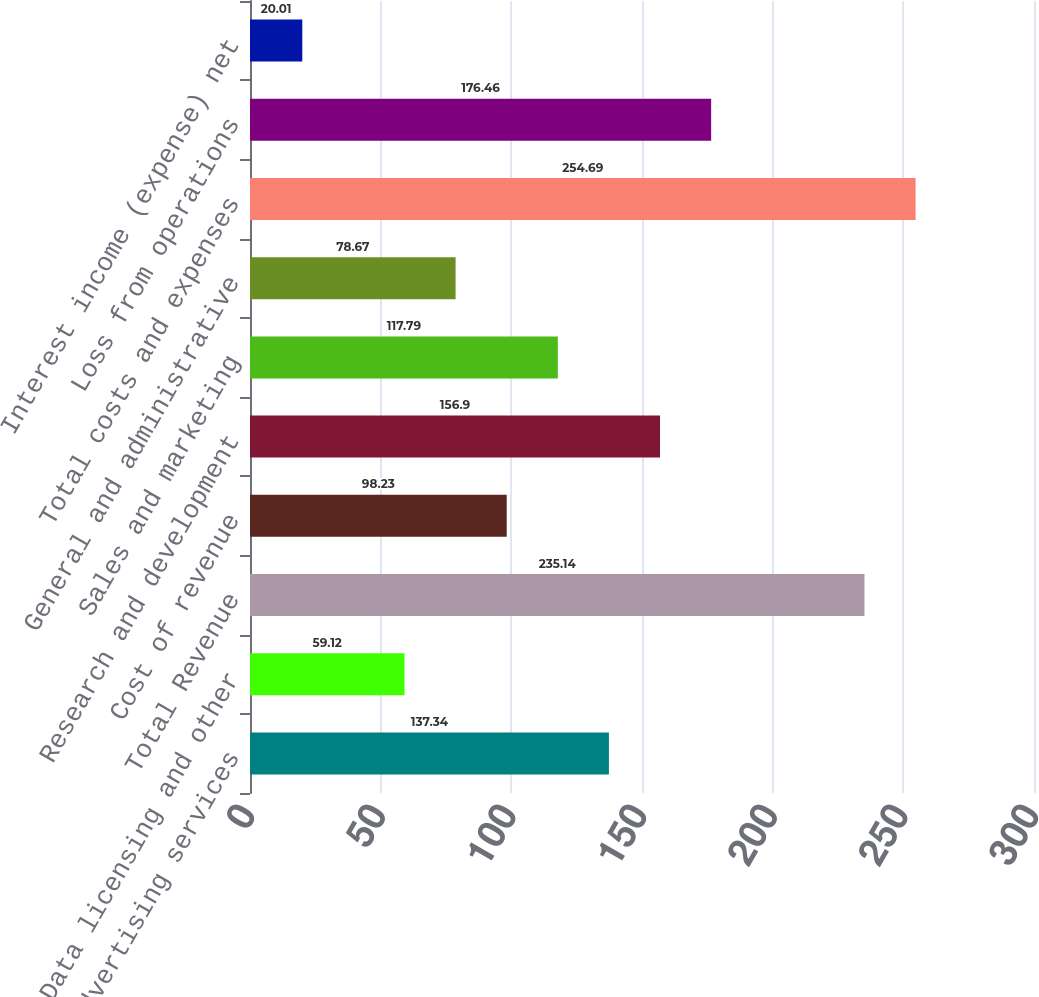Convert chart. <chart><loc_0><loc_0><loc_500><loc_500><bar_chart><fcel>Advertising services<fcel>Data licensing and other<fcel>Total Revenue<fcel>Cost of revenue<fcel>Research and development<fcel>Sales and marketing<fcel>General and administrative<fcel>Total costs and expenses<fcel>Loss from operations<fcel>Interest income (expense) net<nl><fcel>137.34<fcel>59.12<fcel>235.14<fcel>98.23<fcel>156.9<fcel>117.79<fcel>78.67<fcel>254.69<fcel>176.46<fcel>20.01<nl></chart> 